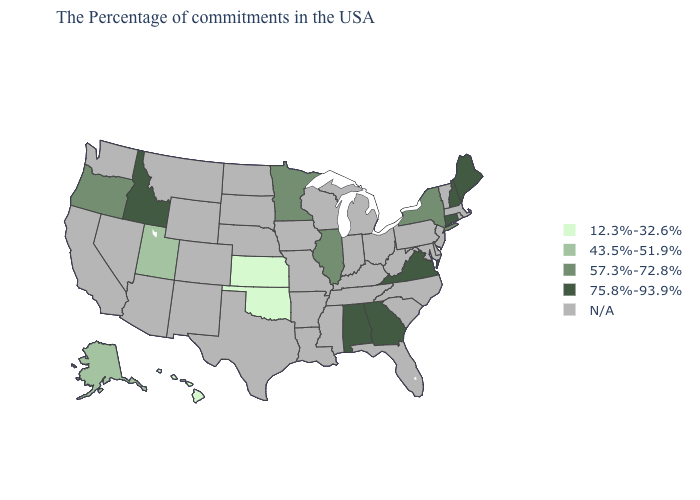Name the states that have a value in the range 75.8%-93.9%?
Keep it brief. Maine, New Hampshire, Connecticut, Virginia, Georgia, Alabama, Idaho. What is the value of Connecticut?
Answer briefly. 75.8%-93.9%. Name the states that have a value in the range 75.8%-93.9%?
Write a very short answer. Maine, New Hampshire, Connecticut, Virginia, Georgia, Alabama, Idaho. Name the states that have a value in the range 75.8%-93.9%?
Write a very short answer. Maine, New Hampshire, Connecticut, Virginia, Georgia, Alabama, Idaho. What is the value of Alabama?
Quick response, please. 75.8%-93.9%. What is the lowest value in the USA?
Short answer required. 12.3%-32.6%. Name the states that have a value in the range 75.8%-93.9%?
Short answer required. Maine, New Hampshire, Connecticut, Virginia, Georgia, Alabama, Idaho. Name the states that have a value in the range 43.5%-51.9%?
Write a very short answer. Utah, Alaska. What is the value of Mississippi?
Concise answer only. N/A. What is the highest value in the Northeast ?
Quick response, please. 75.8%-93.9%. What is the value of Delaware?
Keep it brief. N/A. Does the map have missing data?
Quick response, please. Yes. What is the value of California?
Answer briefly. N/A. Does the first symbol in the legend represent the smallest category?
Be succinct. Yes. 